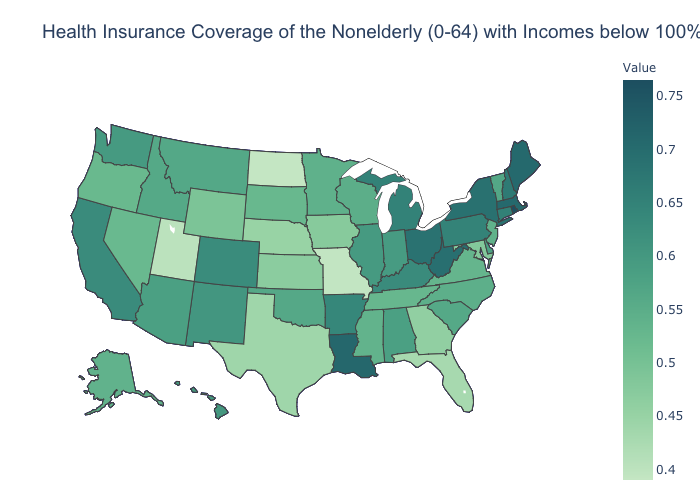Does North Dakota have the lowest value in the USA?
Quick response, please. Yes. Among the states that border Illinois , does Missouri have the lowest value?
Concise answer only. Yes. Does North Carolina have the lowest value in the South?
Keep it brief. No. 